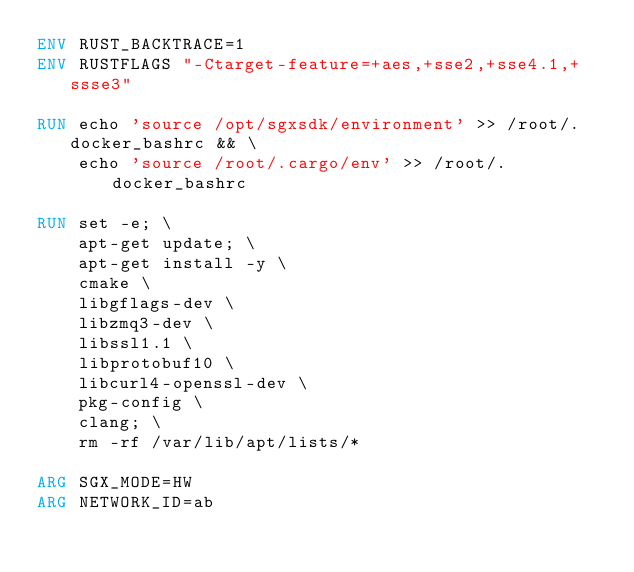<code> <loc_0><loc_0><loc_500><loc_500><_Dockerfile_>ENV RUST_BACKTRACE=1
ENV RUSTFLAGS "-Ctarget-feature=+aes,+sse2,+sse4.1,+ssse3"

RUN echo 'source /opt/sgxsdk/environment' >> /root/.docker_bashrc && \
    echo 'source /root/.cargo/env' >> /root/.docker_bashrc

RUN set -e; \
    apt-get update; \
    apt-get install -y \
    cmake \
    libgflags-dev \
    libzmq3-dev \
    libssl1.1 \
    libprotobuf10 \
    libcurl4-openssl-dev \
    pkg-config \
    clang; \
    rm -rf /var/lib/apt/lists/*

ARG SGX_MODE=HW
ARG NETWORK_ID=ab
</code> 